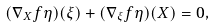Convert formula to latex. <formula><loc_0><loc_0><loc_500><loc_500>( \nabla _ { X } f \eta ) ( \xi ) + ( \nabla _ { \xi } f \eta ) ( X ) = 0 ,</formula> 